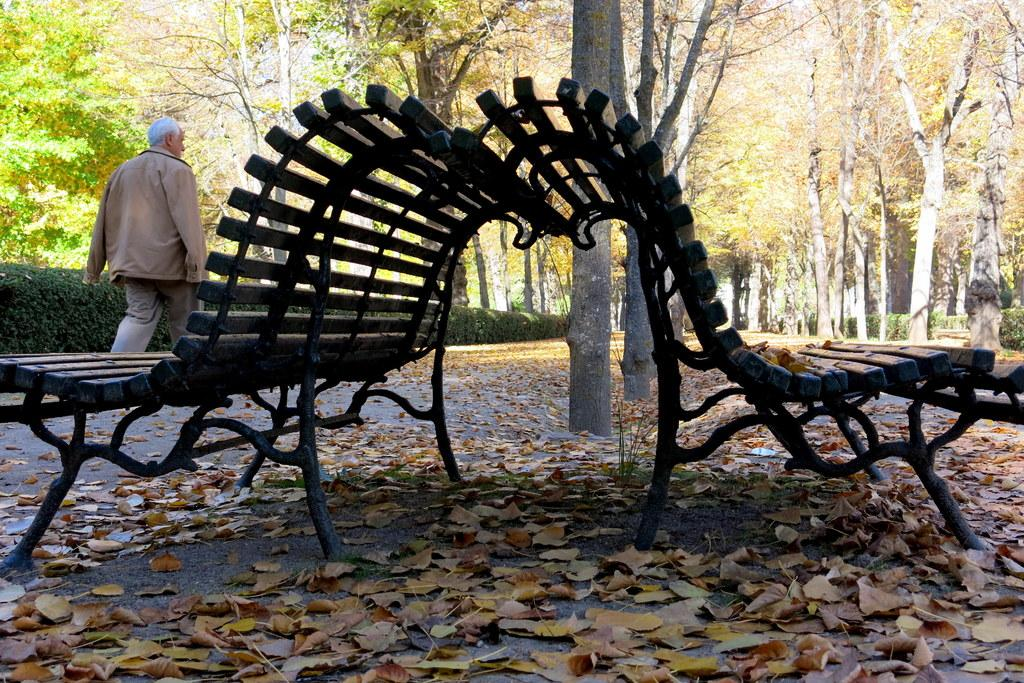How many benches can be seen in the image? There are 2 benches in the image. What is the person in the image doing? There is a person walking in the image. What can be seen in the background of the image? There are trees in the background of the image. Are there any additional benches visible in the image? Yes, there are additional benches in the background of the image. What type of wrist injury does the person in the image have? There is no indication of a wrist injury in the image; the person is simply walking. Is there a stranger in the image? The provided facts do not mention a stranger, so we cannot determine if there is one in the image. 